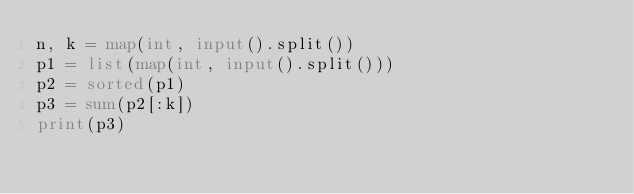<code> <loc_0><loc_0><loc_500><loc_500><_Python_>n, k = map(int, input().split())
p1 = list(map(int, input().split()))
p2 = sorted(p1)
p3 = sum(p2[:k])
print(p3)</code> 